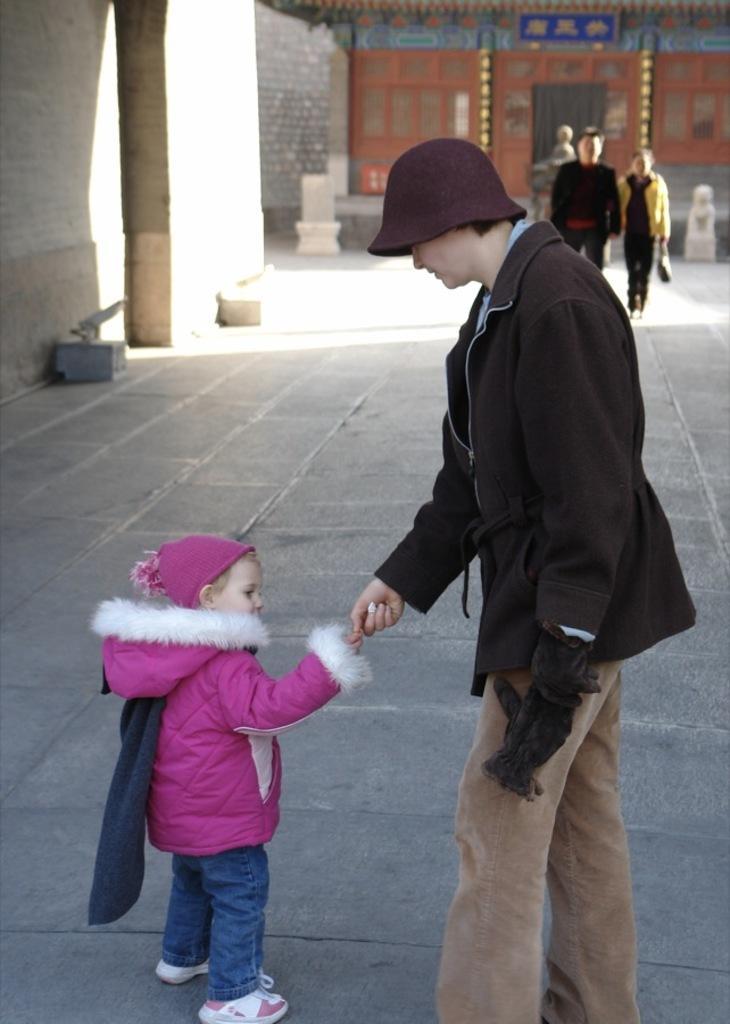In one or two sentences, can you explain what this image depicts? In this image I can see a person holding a baby hand and baby wearing a pink color sweater and standing on floor and I can see the wall and building and persons visible in the background 